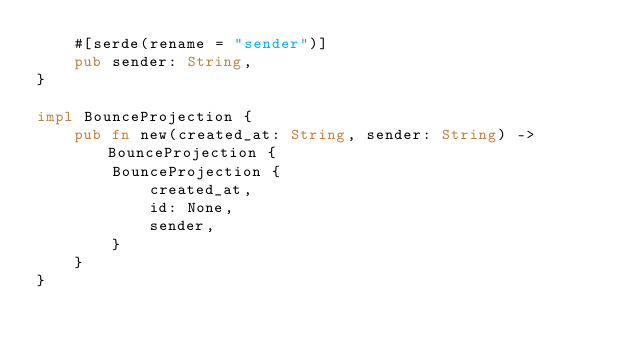<code> <loc_0><loc_0><loc_500><loc_500><_Rust_>    #[serde(rename = "sender")]
    pub sender: String,
}

impl BounceProjection {
    pub fn new(created_at: String, sender: String) -> BounceProjection {
        BounceProjection {
            created_at,
            id: None,
            sender,
        }
    }
}


</code> 